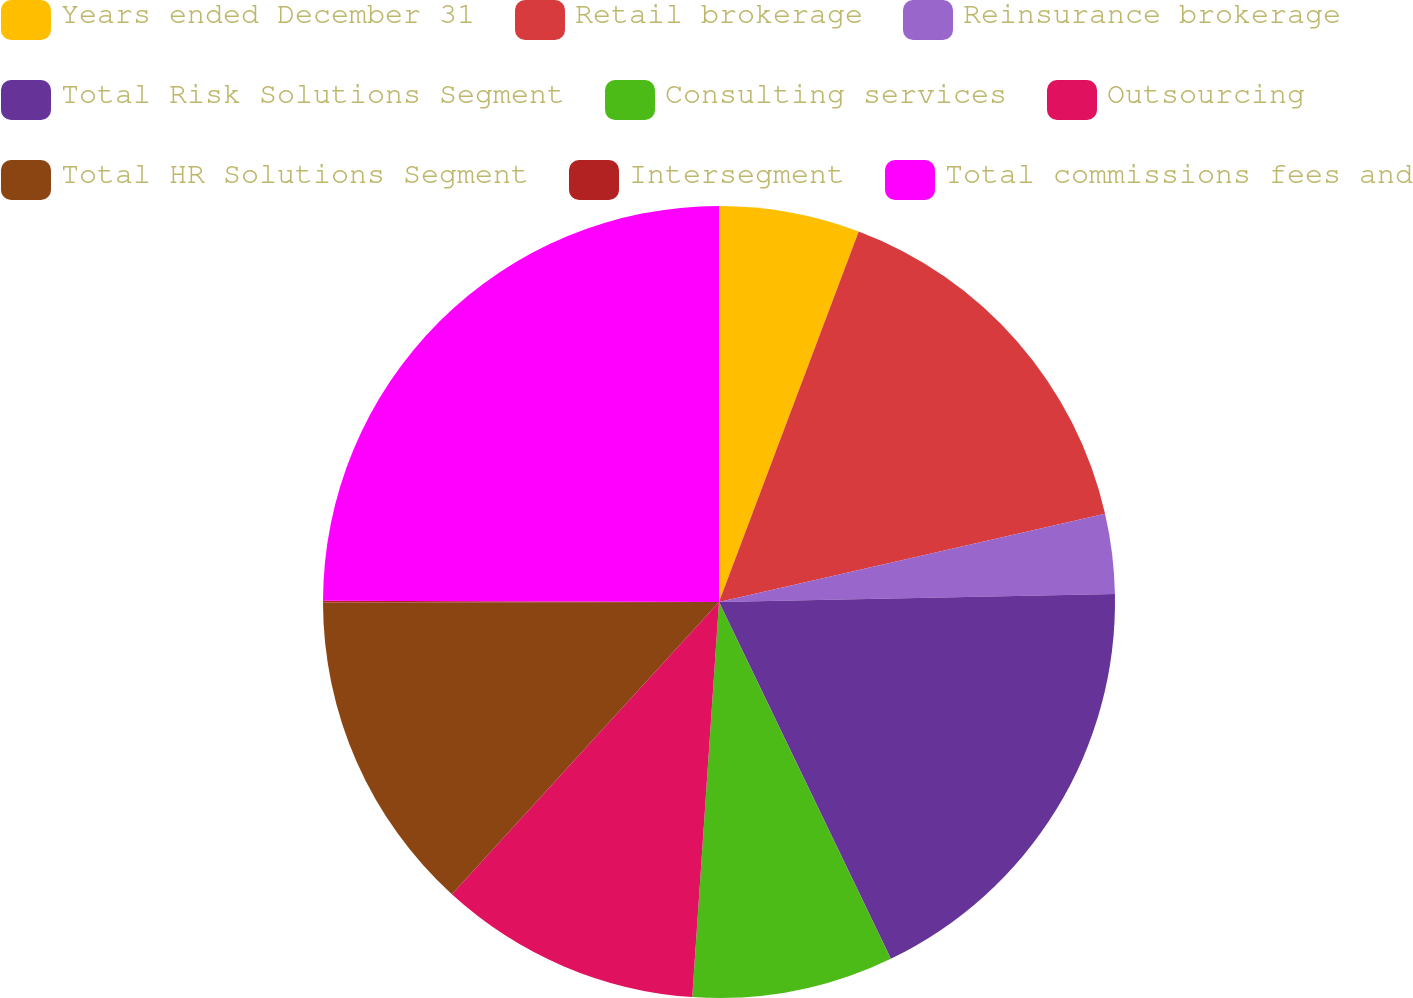Convert chart to OTSL. <chart><loc_0><loc_0><loc_500><loc_500><pie_chart><fcel>Years ended December 31<fcel>Retail brokerage<fcel>Reinsurance brokerage<fcel>Total Risk Solutions Segment<fcel>Consulting services<fcel>Outsourcing<fcel>Total HR Solutions Segment<fcel>Intersegment<fcel>Total commissions fees and<nl><fcel>5.74%<fcel>15.69%<fcel>3.25%<fcel>18.18%<fcel>8.22%<fcel>10.71%<fcel>13.2%<fcel>0.07%<fcel>24.95%<nl></chart> 